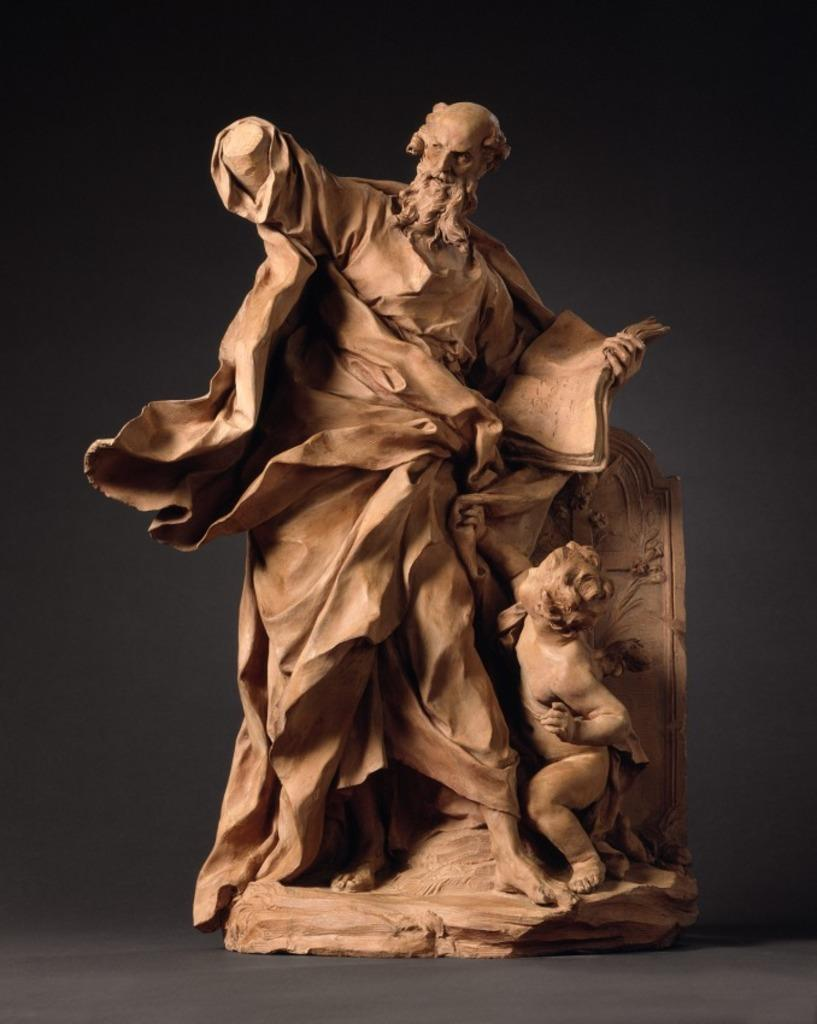What is the main subject of the image? There is a sculpture in the image. What type of authority is depicted in the sculpture? There is no indication of any authority figure in the image, as it only features a sculpture. How many steps are visible in the image? There are no steps visible in the image, as it only features a sculpture. 